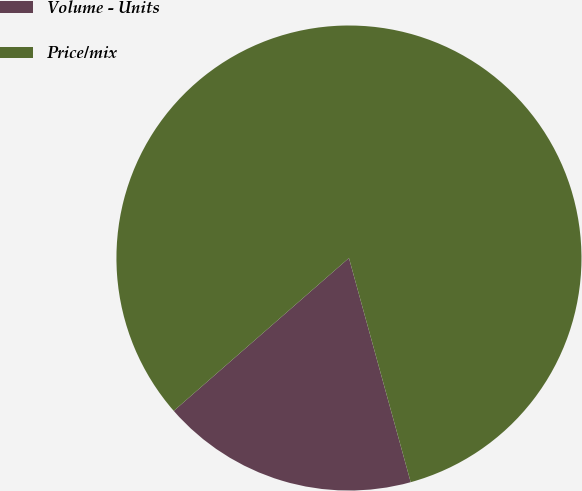Convert chart. <chart><loc_0><loc_0><loc_500><loc_500><pie_chart><fcel>Volume - Units<fcel>Price/mix<nl><fcel>17.86%<fcel>82.14%<nl></chart> 